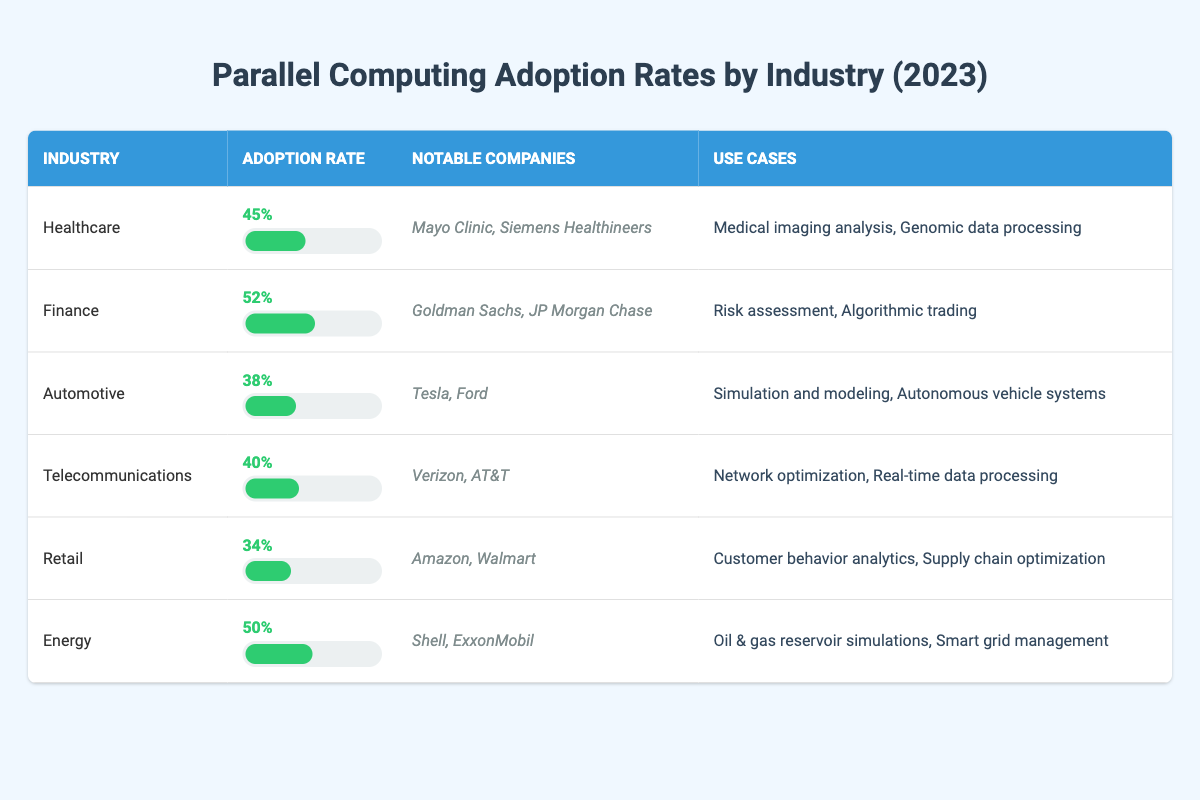What industry has the highest adoption rate of parallel computing in 2023? By inspecting the table, we can see that the Finance industry has the highest adoption rate at 52%.
Answer: 52% Which two industries have an adoption rate that is higher than 40%? Referring to the table, we see that Finance (52%) and Energy (50%) have adoption rates higher than 40%.
Answer: Finance and Energy What is the average adoption rate of parallel computing across all listed industries? To find the average, we sum the adoption rates (45 + 52 + 38 + 40 + 34 + 50 = 259) and divide by the number of industries (6). Thus, the average adoption rate is 259/6 which equals approximately 43.2%.
Answer: 43.2% Is it true that the Automotive industry has a lower adoption rate than the Retail industry? By checking the table, the Automotive industry has an adoption rate of 38%, while the Retail industry has an adoption rate of 34%. Since 38% is greater than 34%, the statement is false.
Answer: False Which notable companies are associated with the Telecommunications industry? Looking at the table, the notable companies listed under the Telecommunications industry are Verizon and AT&T.
Answer: Verizon and AT&T What is the difference in adoption rates between the Healthcare and Automotive industries? The adoption rate for Healthcare is 45%, and for Automotive, it is 38%. The difference is calculated by subtracting the Automotive rate from the Healthcare rate (45 - 38 = 7).
Answer: 7 How many industries mentioned have notable companies that deal with risk assessment? From the table, only the Finance industry, which includes Goldman Sachs and JP Morgan Chase, deals with risk assessment. Therefore, there is only one industry that mentions this.
Answer: 1 Which industry and associated companies have the same adoption rate? By examining the table, we see that both Healthcare (45%) and Energy (50%) have unique adoption rates. No other industry shares these rates, indicating each has its own percentage.
Answer: Each has a unique rate 